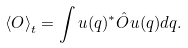Convert formula to latex. <formula><loc_0><loc_0><loc_500><loc_500>\left < O \right > _ { t } = \int u ( q ) ^ { * } \hat { O } u ( q ) d q .</formula> 